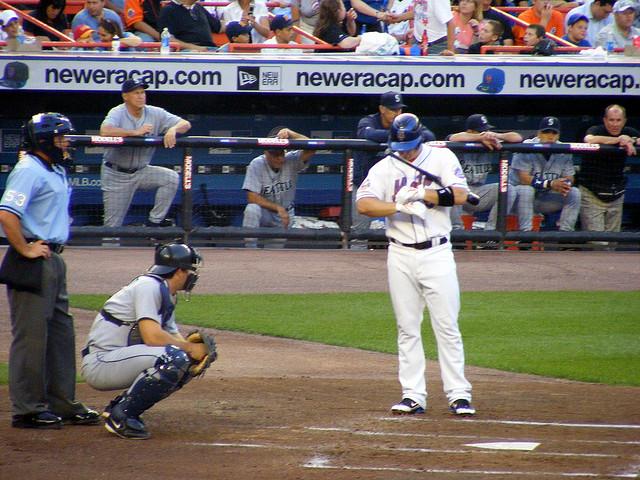What is batter doing?
Quick response, please. Adjusting glove. What sport is this?
Give a very brief answer. Baseball. What team is the batter on?
Concise answer only. Mets. 